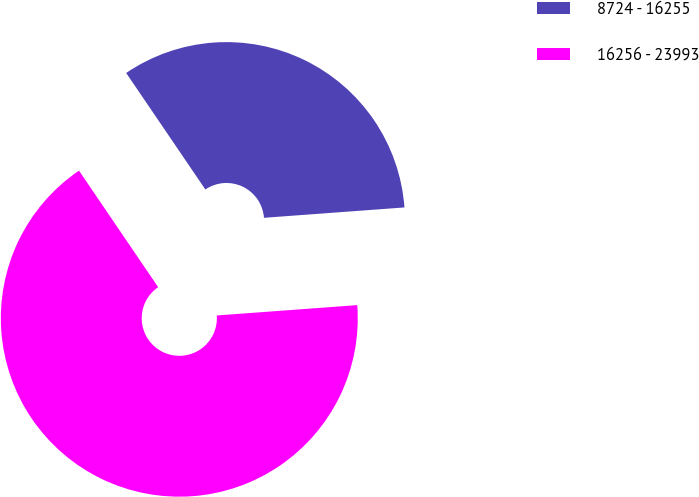Convert chart to OTSL. <chart><loc_0><loc_0><loc_500><loc_500><pie_chart><fcel>8724 - 16255<fcel>16256 - 23993<nl><fcel>33.33%<fcel>66.67%<nl></chart> 